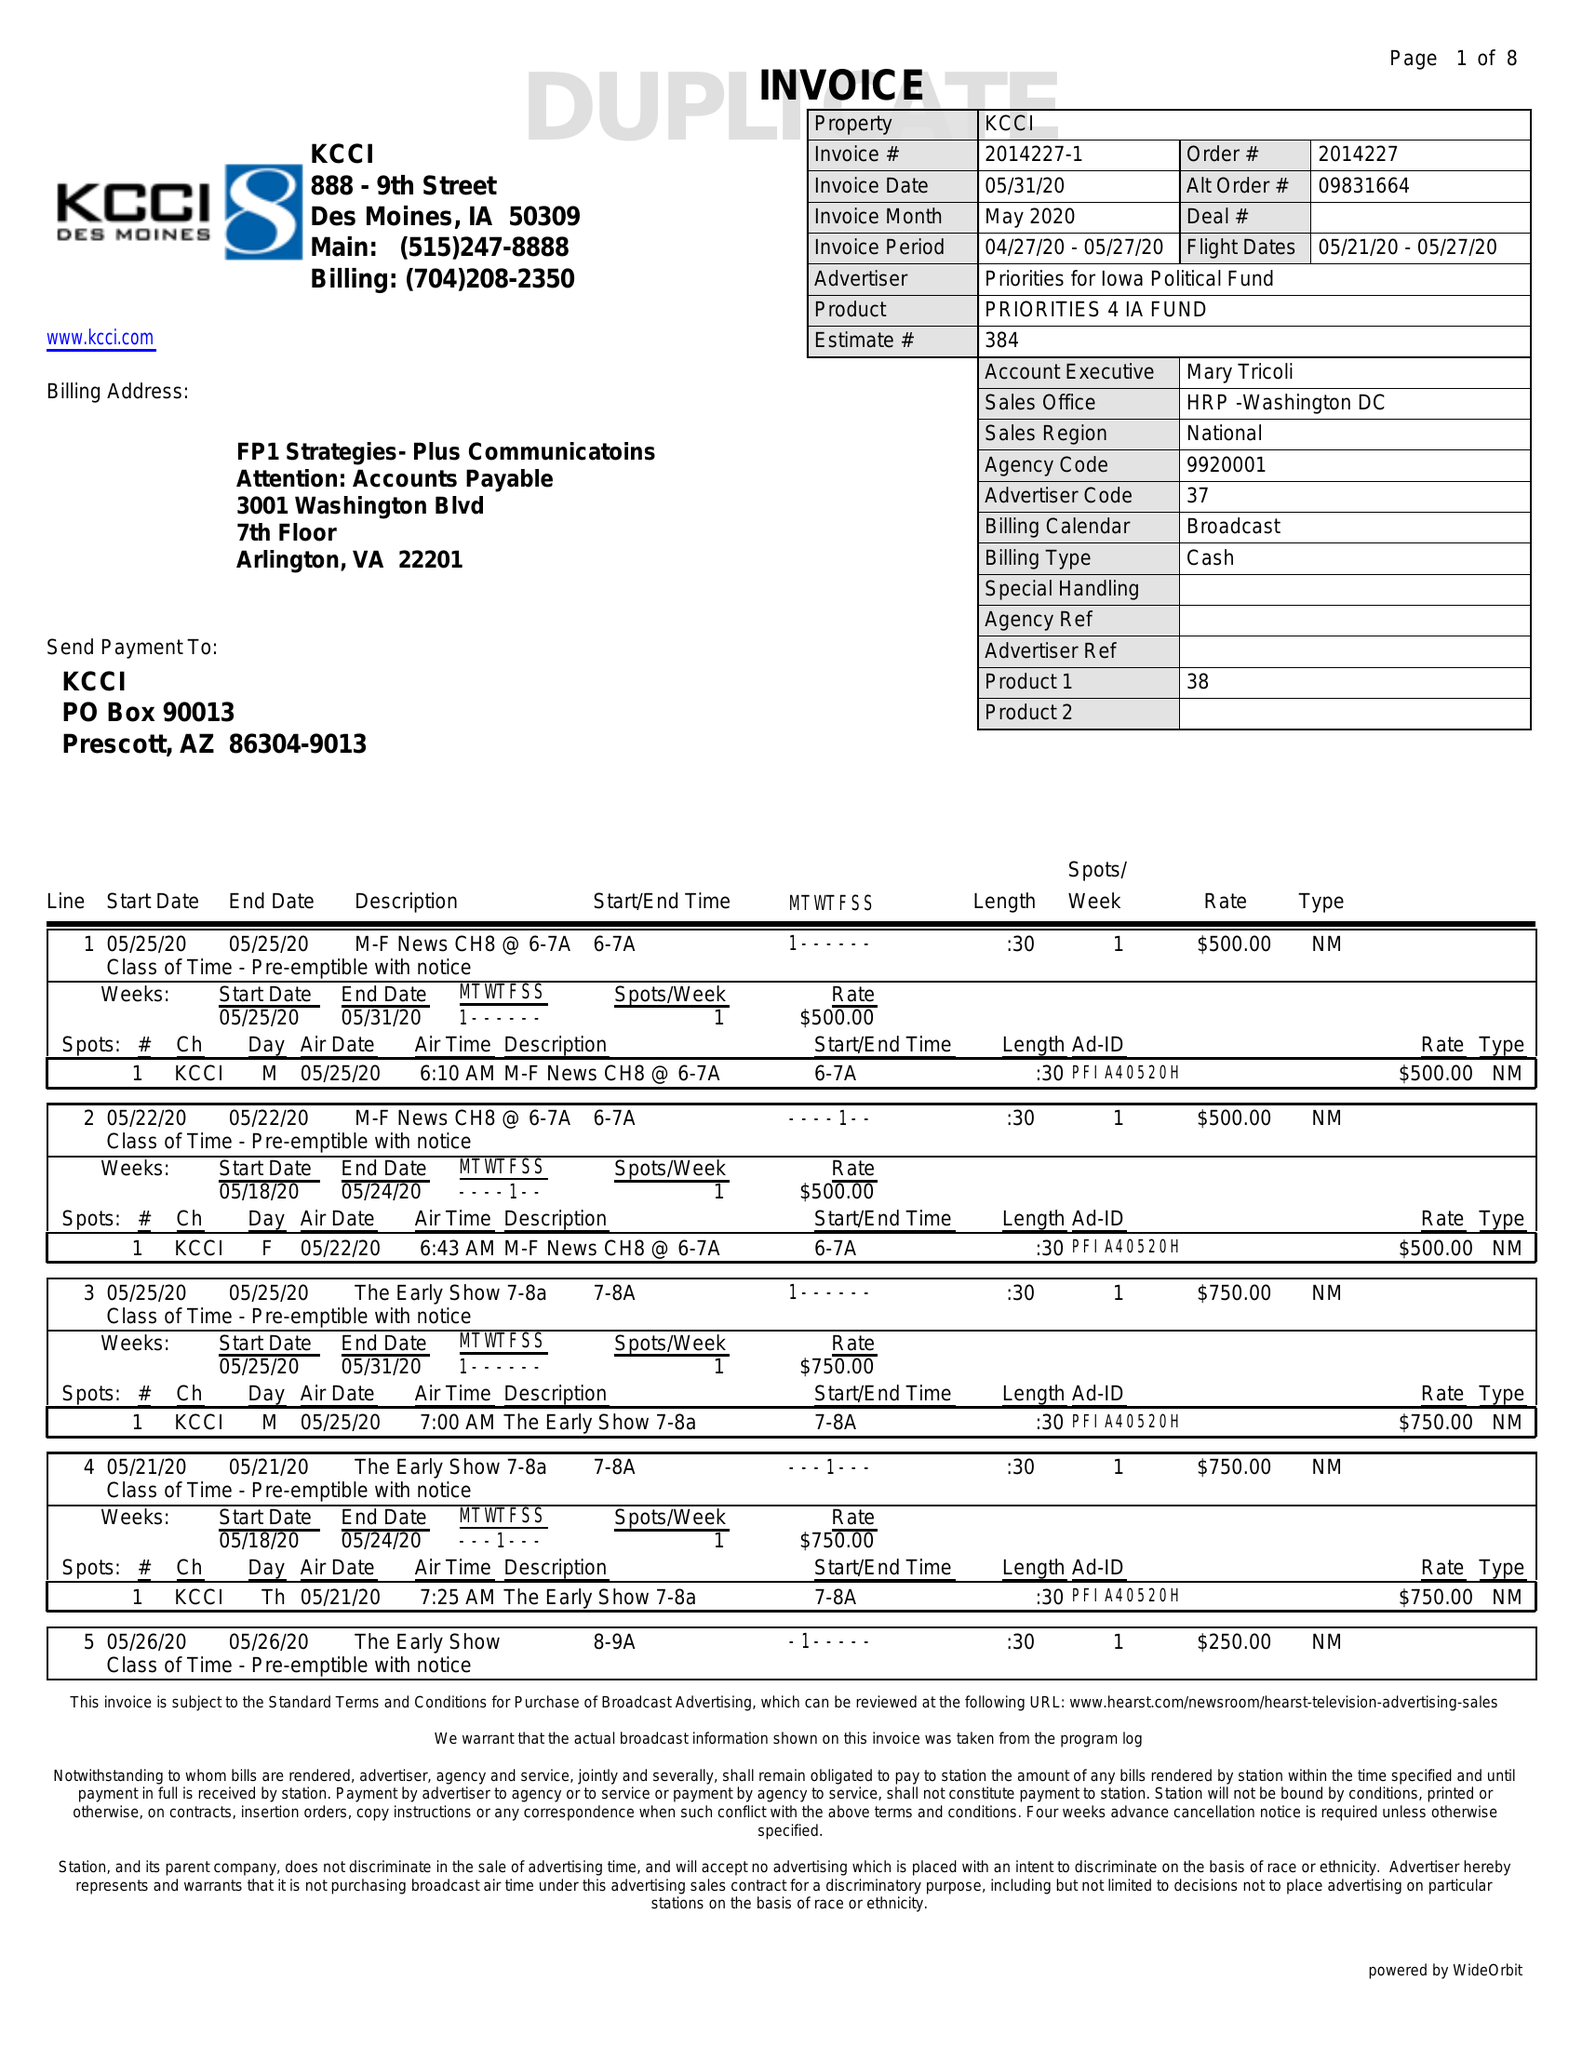What is the value for the flight_to?
Answer the question using a single word or phrase. 05/27/20 